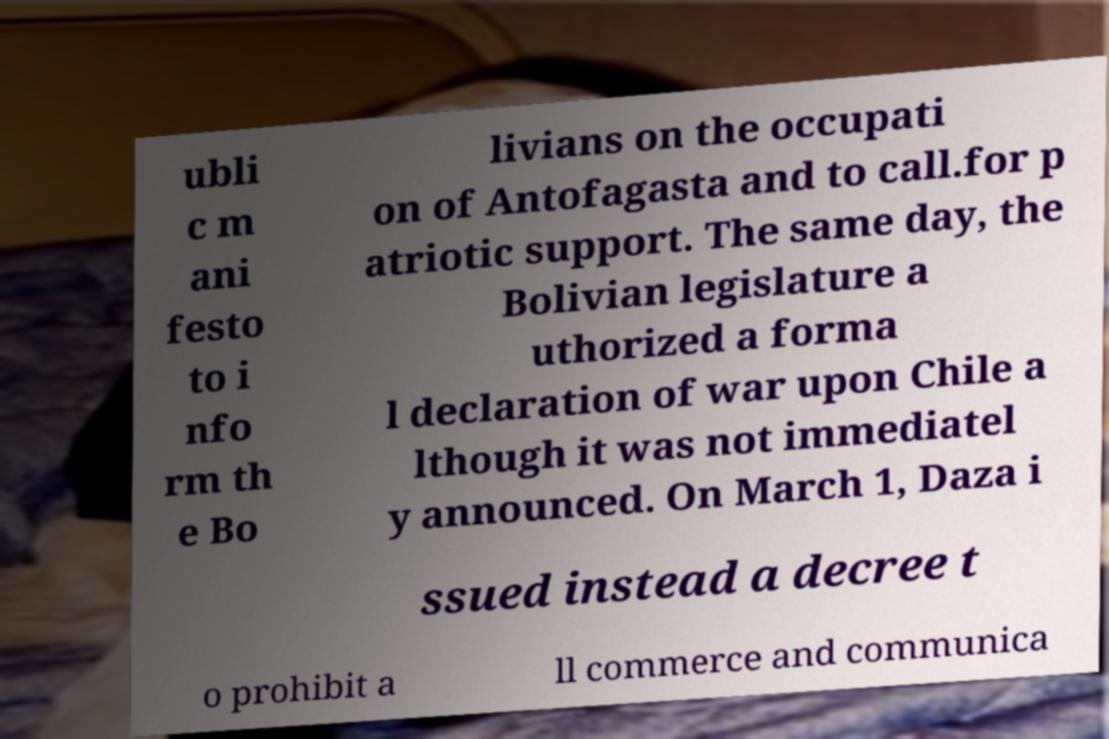Please read and relay the text visible in this image. What does it say? ubli c m ani festo to i nfo rm th e Bo livians on the occupati on of Antofagasta and to call.for p atriotic support. The same day, the Bolivian legislature a uthorized a forma l declaration of war upon Chile a lthough it was not immediatel y announced. On March 1, Daza i ssued instead a decree t o prohibit a ll commerce and communica 